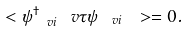Convert formula to latex. <formula><loc_0><loc_0><loc_500><loc_500>\ < \psi _ { \ v i } ^ { \dag } \ v \tau \psi _ { \ v i } \ > = 0 .</formula> 